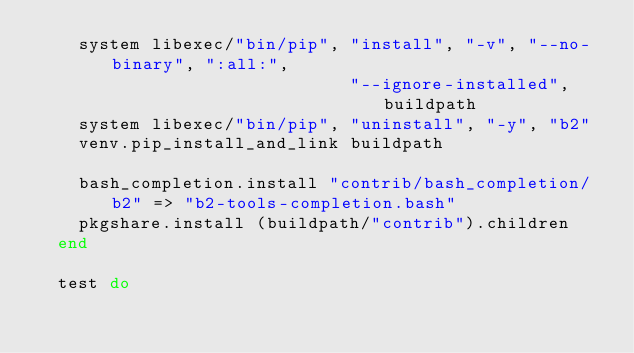Convert code to text. <code><loc_0><loc_0><loc_500><loc_500><_Ruby_>    system libexec/"bin/pip", "install", "-v", "--no-binary", ":all:",
                              "--ignore-installed", buildpath
    system libexec/"bin/pip", "uninstall", "-y", "b2"
    venv.pip_install_and_link buildpath

    bash_completion.install "contrib/bash_completion/b2" => "b2-tools-completion.bash"
    pkgshare.install (buildpath/"contrib").children
  end

  test do</code> 